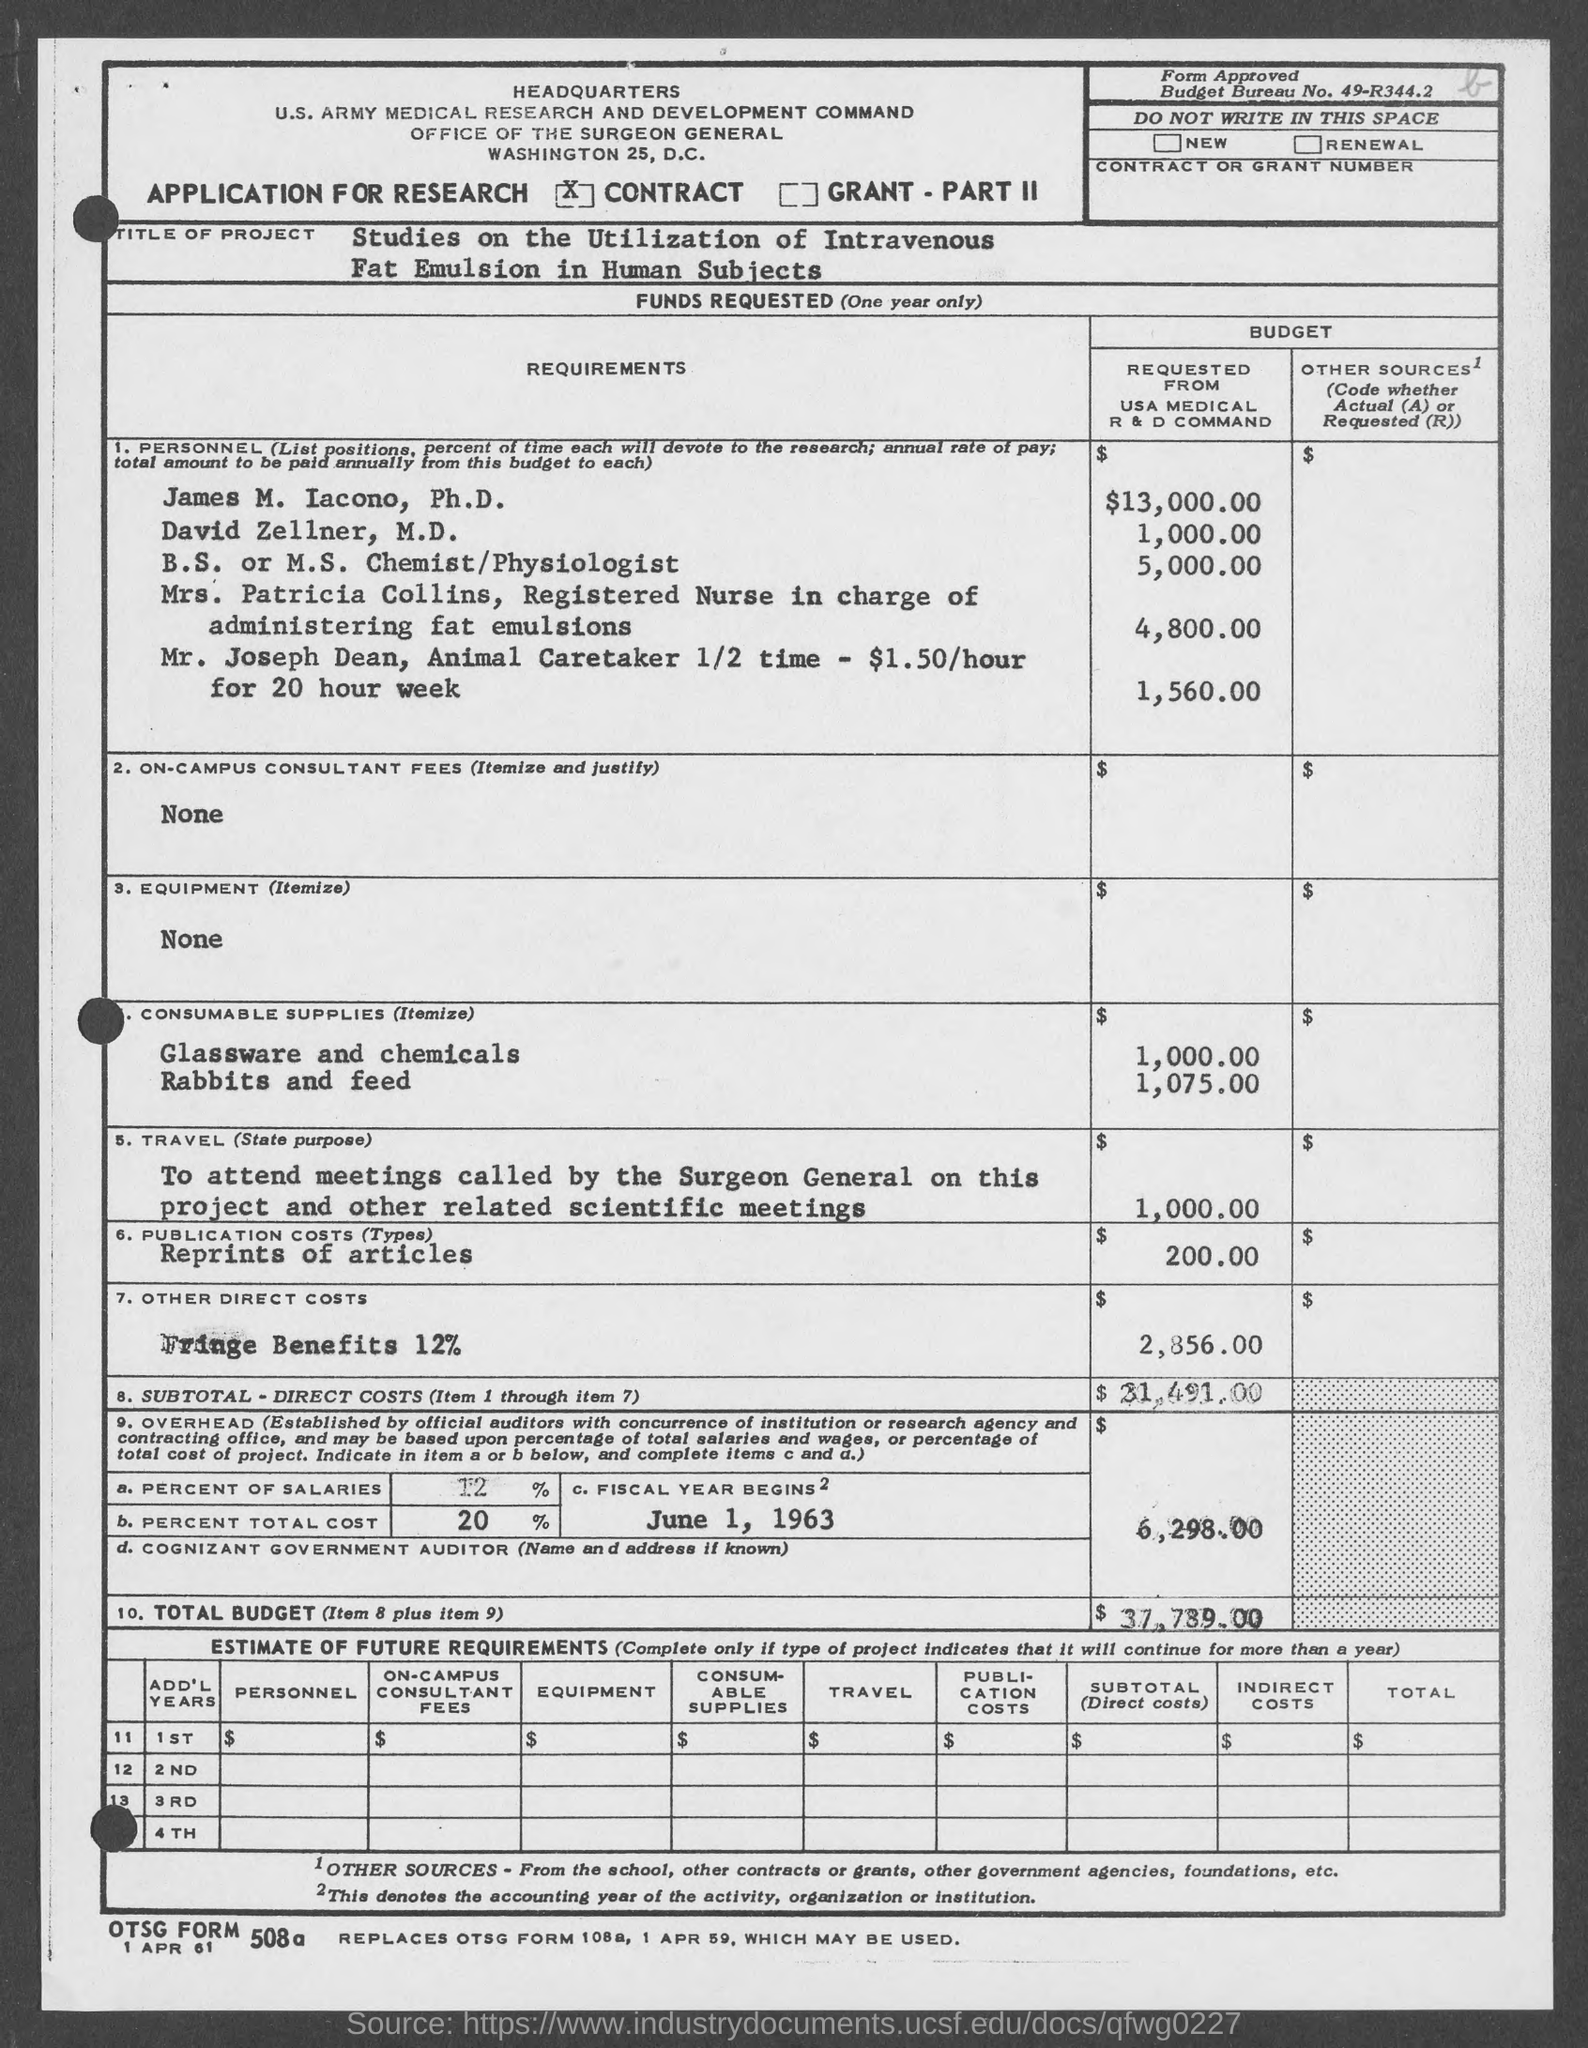How much did James M. Iacono, Ph.D. requested from USA medical R & D Command?
Provide a succinct answer. $13,000.00. How much did David Zellner, M.D. requested from USA medical R & D Command?
Provide a short and direct response. 1,000.00. How much did Mr. Joseph Dean requested from USA medical R & D Command?
Provide a short and direct response. 1,560.00. 